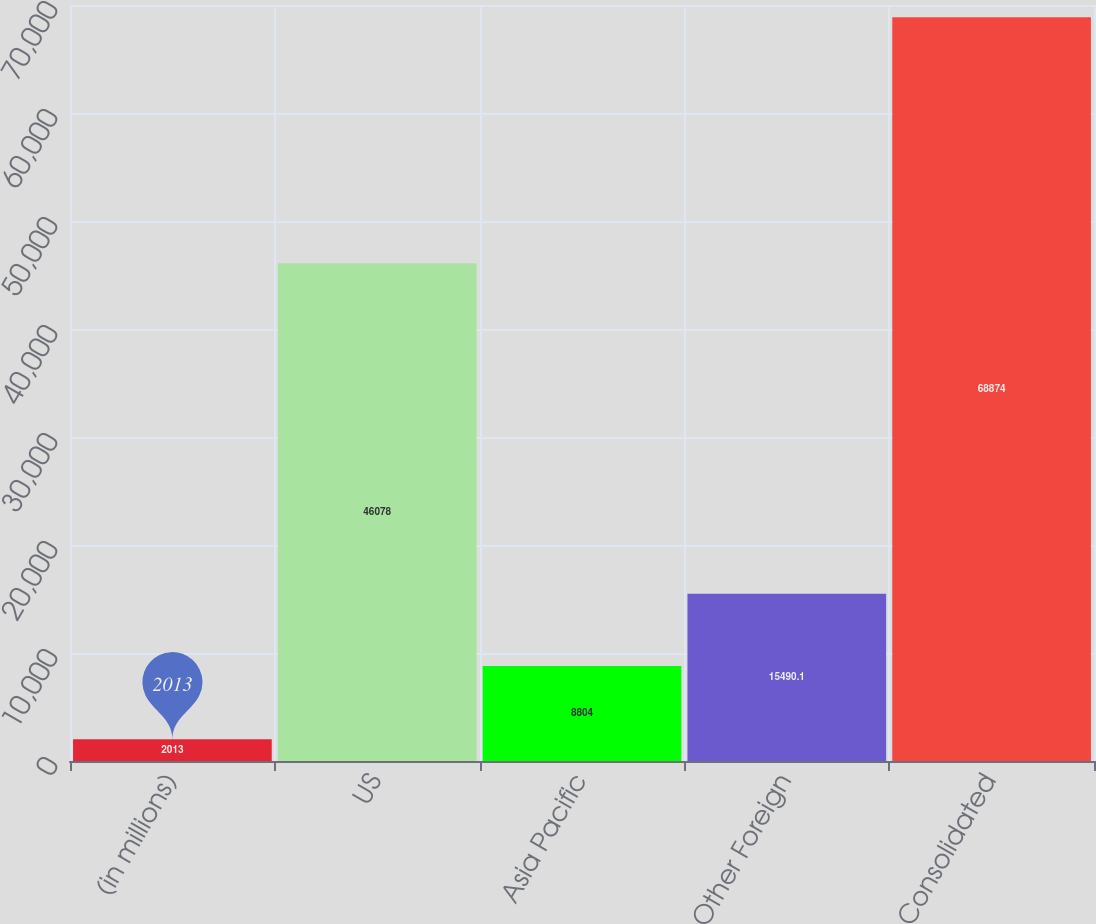Convert chart to OTSL. <chart><loc_0><loc_0><loc_500><loc_500><bar_chart><fcel>(in millions)<fcel>US<fcel>Asia Pacific<fcel>Other Foreign<fcel>Consolidated<nl><fcel>2013<fcel>46078<fcel>8804<fcel>15490.1<fcel>68874<nl></chart> 